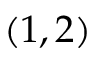Convert formula to latex. <formula><loc_0><loc_0><loc_500><loc_500>( 1 , 2 )</formula> 